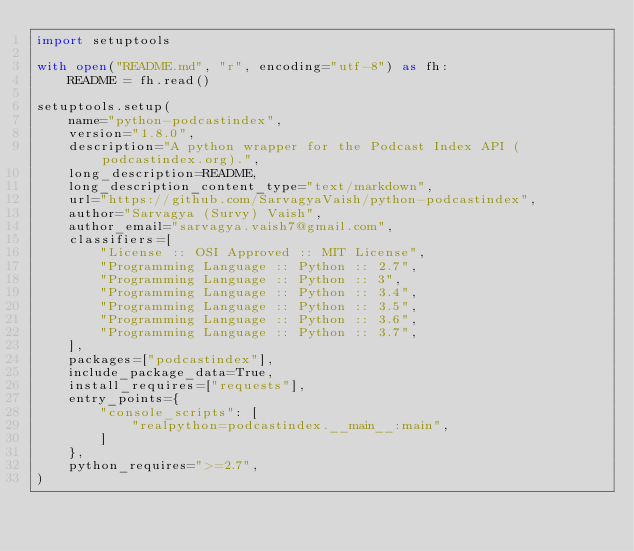Convert code to text. <code><loc_0><loc_0><loc_500><loc_500><_Python_>import setuptools

with open("README.md", "r", encoding="utf-8") as fh:
    README = fh.read()

setuptools.setup(
    name="python-podcastindex",
    version="1.8.0",
    description="A python wrapper for the Podcast Index API (podcastindex.org).",
    long_description=README,
    long_description_content_type="text/markdown",
    url="https://github.com/SarvagyaVaish/python-podcastindex",
    author="Sarvagya (Survy) Vaish",
    author_email="sarvagya.vaish7@gmail.com",
    classifiers=[
        "License :: OSI Approved :: MIT License",
        "Programming Language :: Python :: 2.7",
        "Programming Language :: Python :: 3",
        "Programming Language :: Python :: 3.4",
        "Programming Language :: Python :: 3.5",
        "Programming Language :: Python :: 3.6",
        "Programming Language :: Python :: 3.7",
    ],
    packages=["podcastindex"],
    include_package_data=True,
    install_requires=["requests"],
    entry_points={
        "console_scripts": [
            "realpython=podcastindex.__main__:main",
        ]
    },
    python_requires=">=2.7",
)
</code> 